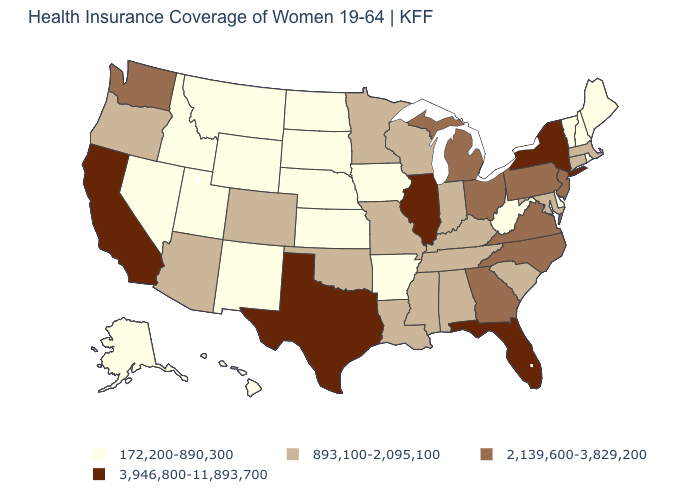Which states have the lowest value in the Northeast?
Short answer required. Maine, New Hampshire, Rhode Island, Vermont. Is the legend a continuous bar?
Concise answer only. No. Which states have the lowest value in the MidWest?
Answer briefly. Iowa, Kansas, Nebraska, North Dakota, South Dakota. What is the value of Alabama?
Write a very short answer. 893,100-2,095,100. Name the states that have a value in the range 2,139,600-3,829,200?
Be succinct. Georgia, Michigan, New Jersey, North Carolina, Ohio, Pennsylvania, Virginia, Washington. What is the lowest value in states that border Iowa?
Be succinct. 172,200-890,300. Name the states that have a value in the range 2,139,600-3,829,200?
Give a very brief answer. Georgia, Michigan, New Jersey, North Carolina, Ohio, Pennsylvania, Virginia, Washington. Name the states that have a value in the range 893,100-2,095,100?
Write a very short answer. Alabama, Arizona, Colorado, Connecticut, Indiana, Kentucky, Louisiana, Maryland, Massachusetts, Minnesota, Mississippi, Missouri, Oklahoma, Oregon, South Carolina, Tennessee, Wisconsin. What is the value of Washington?
Write a very short answer. 2,139,600-3,829,200. How many symbols are there in the legend?
Quick response, please. 4. Name the states that have a value in the range 172,200-890,300?
Give a very brief answer. Alaska, Arkansas, Delaware, Hawaii, Idaho, Iowa, Kansas, Maine, Montana, Nebraska, Nevada, New Hampshire, New Mexico, North Dakota, Rhode Island, South Dakota, Utah, Vermont, West Virginia, Wyoming. Name the states that have a value in the range 893,100-2,095,100?
Concise answer only. Alabama, Arizona, Colorado, Connecticut, Indiana, Kentucky, Louisiana, Maryland, Massachusetts, Minnesota, Mississippi, Missouri, Oklahoma, Oregon, South Carolina, Tennessee, Wisconsin. What is the highest value in the USA?
Keep it brief. 3,946,800-11,893,700. Name the states that have a value in the range 3,946,800-11,893,700?
Short answer required. California, Florida, Illinois, New York, Texas. Does Illinois have the lowest value in the USA?
Write a very short answer. No. 